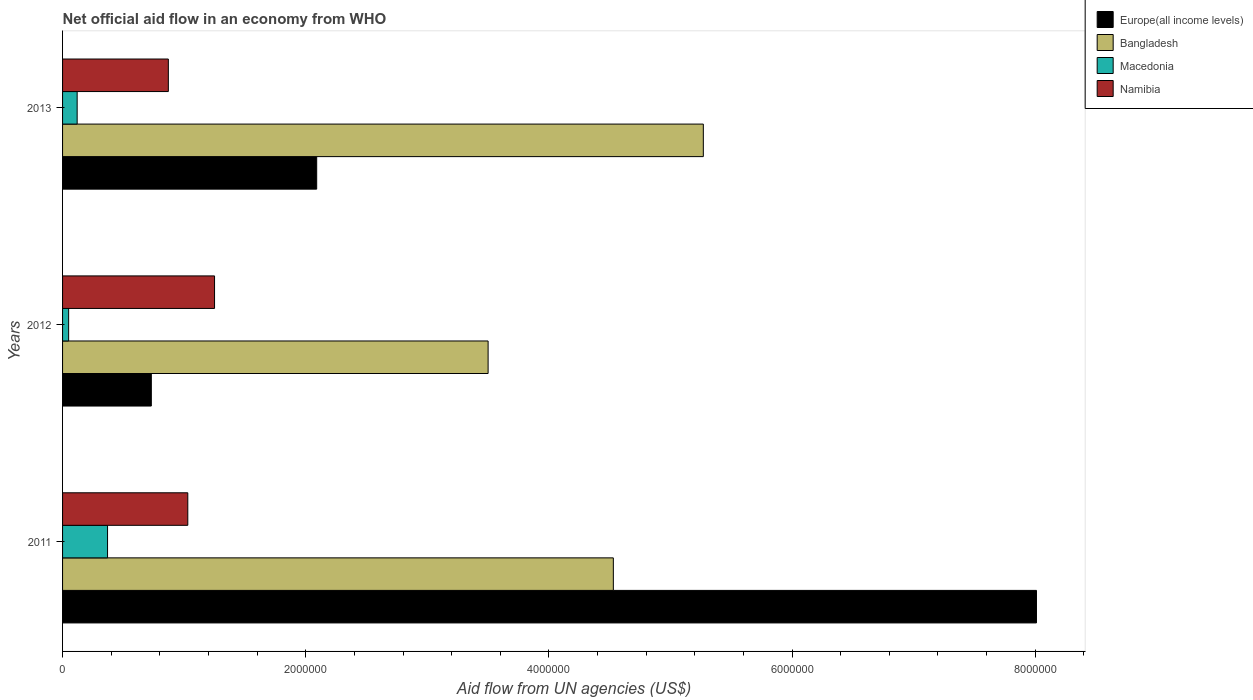Are the number of bars per tick equal to the number of legend labels?
Offer a very short reply. Yes. How many bars are there on the 1st tick from the bottom?
Your response must be concise. 4. What is the label of the 2nd group of bars from the top?
Make the answer very short. 2012. In how many cases, is the number of bars for a given year not equal to the number of legend labels?
Your answer should be very brief. 0. What is the net official aid flow in Europe(all income levels) in 2013?
Keep it short and to the point. 2.09e+06. Across all years, what is the maximum net official aid flow in Namibia?
Provide a short and direct response. 1.25e+06. In which year was the net official aid flow in Europe(all income levels) maximum?
Offer a very short reply. 2011. What is the total net official aid flow in Namibia in the graph?
Keep it short and to the point. 3.15e+06. What is the difference between the net official aid flow in Bangladesh in 2011 and that in 2012?
Your answer should be very brief. 1.03e+06. What is the difference between the net official aid flow in Macedonia in 2011 and the net official aid flow in Europe(all income levels) in 2013?
Offer a terse response. -1.72e+06. What is the average net official aid flow in Europe(all income levels) per year?
Give a very brief answer. 3.61e+06. In the year 2013, what is the difference between the net official aid flow in Macedonia and net official aid flow in Namibia?
Your answer should be compact. -7.50e+05. What is the ratio of the net official aid flow in Bangladesh in 2012 to that in 2013?
Your answer should be compact. 0.66. Is the net official aid flow in Bangladesh in 2012 less than that in 2013?
Provide a succinct answer. Yes. What is the difference between the highest and the second highest net official aid flow in Macedonia?
Provide a short and direct response. 2.50e+05. What is the difference between the highest and the lowest net official aid flow in Europe(all income levels)?
Provide a short and direct response. 7.28e+06. In how many years, is the net official aid flow in Macedonia greater than the average net official aid flow in Macedonia taken over all years?
Ensure brevity in your answer.  1. Is it the case that in every year, the sum of the net official aid flow in Bangladesh and net official aid flow in Namibia is greater than the sum of net official aid flow in Europe(all income levels) and net official aid flow in Macedonia?
Provide a short and direct response. Yes. What does the 1st bar from the top in 2012 represents?
Your response must be concise. Namibia. What does the 1st bar from the bottom in 2012 represents?
Your answer should be very brief. Europe(all income levels). How many bars are there?
Your response must be concise. 12. Are all the bars in the graph horizontal?
Keep it short and to the point. Yes. How many years are there in the graph?
Make the answer very short. 3. Are the values on the major ticks of X-axis written in scientific E-notation?
Give a very brief answer. No. Does the graph contain any zero values?
Your answer should be compact. No. Does the graph contain grids?
Make the answer very short. No. What is the title of the graph?
Keep it short and to the point. Net official aid flow in an economy from WHO. Does "Jordan" appear as one of the legend labels in the graph?
Your answer should be very brief. No. What is the label or title of the X-axis?
Offer a very short reply. Aid flow from UN agencies (US$). What is the Aid flow from UN agencies (US$) of Europe(all income levels) in 2011?
Keep it short and to the point. 8.01e+06. What is the Aid flow from UN agencies (US$) of Bangladesh in 2011?
Ensure brevity in your answer.  4.53e+06. What is the Aid flow from UN agencies (US$) of Namibia in 2011?
Ensure brevity in your answer.  1.03e+06. What is the Aid flow from UN agencies (US$) in Europe(all income levels) in 2012?
Give a very brief answer. 7.30e+05. What is the Aid flow from UN agencies (US$) in Bangladesh in 2012?
Keep it short and to the point. 3.50e+06. What is the Aid flow from UN agencies (US$) of Namibia in 2012?
Keep it short and to the point. 1.25e+06. What is the Aid flow from UN agencies (US$) in Europe(all income levels) in 2013?
Your response must be concise. 2.09e+06. What is the Aid flow from UN agencies (US$) of Bangladesh in 2013?
Your answer should be very brief. 5.27e+06. What is the Aid flow from UN agencies (US$) in Namibia in 2013?
Make the answer very short. 8.70e+05. Across all years, what is the maximum Aid flow from UN agencies (US$) in Europe(all income levels)?
Give a very brief answer. 8.01e+06. Across all years, what is the maximum Aid flow from UN agencies (US$) of Bangladesh?
Provide a short and direct response. 5.27e+06. Across all years, what is the maximum Aid flow from UN agencies (US$) in Namibia?
Give a very brief answer. 1.25e+06. Across all years, what is the minimum Aid flow from UN agencies (US$) in Europe(all income levels)?
Offer a terse response. 7.30e+05. Across all years, what is the minimum Aid flow from UN agencies (US$) in Bangladesh?
Your response must be concise. 3.50e+06. Across all years, what is the minimum Aid flow from UN agencies (US$) in Macedonia?
Offer a terse response. 5.00e+04. Across all years, what is the minimum Aid flow from UN agencies (US$) of Namibia?
Offer a very short reply. 8.70e+05. What is the total Aid flow from UN agencies (US$) in Europe(all income levels) in the graph?
Provide a short and direct response. 1.08e+07. What is the total Aid flow from UN agencies (US$) in Bangladesh in the graph?
Your answer should be very brief. 1.33e+07. What is the total Aid flow from UN agencies (US$) in Macedonia in the graph?
Your answer should be very brief. 5.40e+05. What is the total Aid flow from UN agencies (US$) of Namibia in the graph?
Make the answer very short. 3.15e+06. What is the difference between the Aid flow from UN agencies (US$) in Europe(all income levels) in 2011 and that in 2012?
Make the answer very short. 7.28e+06. What is the difference between the Aid flow from UN agencies (US$) in Bangladesh in 2011 and that in 2012?
Provide a short and direct response. 1.03e+06. What is the difference between the Aid flow from UN agencies (US$) in Europe(all income levels) in 2011 and that in 2013?
Ensure brevity in your answer.  5.92e+06. What is the difference between the Aid flow from UN agencies (US$) in Bangladesh in 2011 and that in 2013?
Make the answer very short. -7.40e+05. What is the difference between the Aid flow from UN agencies (US$) in Namibia in 2011 and that in 2013?
Keep it short and to the point. 1.60e+05. What is the difference between the Aid flow from UN agencies (US$) in Europe(all income levels) in 2012 and that in 2013?
Your answer should be very brief. -1.36e+06. What is the difference between the Aid flow from UN agencies (US$) of Bangladesh in 2012 and that in 2013?
Keep it short and to the point. -1.77e+06. What is the difference between the Aid flow from UN agencies (US$) in Macedonia in 2012 and that in 2013?
Offer a very short reply. -7.00e+04. What is the difference between the Aid flow from UN agencies (US$) in Europe(all income levels) in 2011 and the Aid flow from UN agencies (US$) in Bangladesh in 2012?
Offer a terse response. 4.51e+06. What is the difference between the Aid flow from UN agencies (US$) of Europe(all income levels) in 2011 and the Aid flow from UN agencies (US$) of Macedonia in 2012?
Offer a very short reply. 7.96e+06. What is the difference between the Aid flow from UN agencies (US$) of Europe(all income levels) in 2011 and the Aid flow from UN agencies (US$) of Namibia in 2012?
Make the answer very short. 6.76e+06. What is the difference between the Aid flow from UN agencies (US$) in Bangladesh in 2011 and the Aid flow from UN agencies (US$) in Macedonia in 2012?
Ensure brevity in your answer.  4.48e+06. What is the difference between the Aid flow from UN agencies (US$) of Bangladesh in 2011 and the Aid flow from UN agencies (US$) of Namibia in 2012?
Provide a short and direct response. 3.28e+06. What is the difference between the Aid flow from UN agencies (US$) in Macedonia in 2011 and the Aid flow from UN agencies (US$) in Namibia in 2012?
Provide a succinct answer. -8.80e+05. What is the difference between the Aid flow from UN agencies (US$) of Europe(all income levels) in 2011 and the Aid flow from UN agencies (US$) of Bangladesh in 2013?
Your response must be concise. 2.74e+06. What is the difference between the Aid flow from UN agencies (US$) in Europe(all income levels) in 2011 and the Aid flow from UN agencies (US$) in Macedonia in 2013?
Your answer should be very brief. 7.89e+06. What is the difference between the Aid flow from UN agencies (US$) of Europe(all income levels) in 2011 and the Aid flow from UN agencies (US$) of Namibia in 2013?
Your answer should be very brief. 7.14e+06. What is the difference between the Aid flow from UN agencies (US$) in Bangladesh in 2011 and the Aid flow from UN agencies (US$) in Macedonia in 2013?
Provide a succinct answer. 4.41e+06. What is the difference between the Aid flow from UN agencies (US$) in Bangladesh in 2011 and the Aid flow from UN agencies (US$) in Namibia in 2013?
Provide a short and direct response. 3.66e+06. What is the difference between the Aid flow from UN agencies (US$) in Macedonia in 2011 and the Aid flow from UN agencies (US$) in Namibia in 2013?
Offer a very short reply. -5.00e+05. What is the difference between the Aid flow from UN agencies (US$) in Europe(all income levels) in 2012 and the Aid flow from UN agencies (US$) in Bangladesh in 2013?
Give a very brief answer. -4.54e+06. What is the difference between the Aid flow from UN agencies (US$) in Europe(all income levels) in 2012 and the Aid flow from UN agencies (US$) in Macedonia in 2013?
Keep it short and to the point. 6.10e+05. What is the difference between the Aid flow from UN agencies (US$) of Bangladesh in 2012 and the Aid flow from UN agencies (US$) of Macedonia in 2013?
Provide a short and direct response. 3.38e+06. What is the difference between the Aid flow from UN agencies (US$) in Bangladesh in 2012 and the Aid flow from UN agencies (US$) in Namibia in 2013?
Your answer should be very brief. 2.63e+06. What is the difference between the Aid flow from UN agencies (US$) of Macedonia in 2012 and the Aid flow from UN agencies (US$) of Namibia in 2013?
Offer a terse response. -8.20e+05. What is the average Aid flow from UN agencies (US$) in Europe(all income levels) per year?
Provide a succinct answer. 3.61e+06. What is the average Aid flow from UN agencies (US$) in Bangladesh per year?
Keep it short and to the point. 4.43e+06. What is the average Aid flow from UN agencies (US$) of Namibia per year?
Your response must be concise. 1.05e+06. In the year 2011, what is the difference between the Aid flow from UN agencies (US$) in Europe(all income levels) and Aid flow from UN agencies (US$) in Bangladesh?
Your answer should be very brief. 3.48e+06. In the year 2011, what is the difference between the Aid flow from UN agencies (US$) in Europe(all income levels) and Aid flow from UN agencies (US$) in Macedonia?
Ensure brevity in your answer.  7.64e+06. In the year 2011, what is the difference between the Aid flow from UN agencies (US$) of Europe(all income levels) and Aid flow from UN agencies (US$) of Namibia?
Provide a succinct answer. 6.98e+06. In the year 2011, what is the difference between the Aid flow from UN agencies (US$) of Bangladesh and Aid flow from UN agencies (US$) of Macedonia?
Make the answer very short. 4.16e+06. In the year 2011, what is the difference between the Aid flow from UN agencies (US$) of Bangladesh and Aid flow from UN agencies (US$) of Namibia?
Your response must be concise. 3.50e+06. In the year 2011, what is the difference between the Aid flow from UN agencies (US$) of Macedonia and Aid flow from UN agencies (US$) of Namibia?
Keep it short and to the point. -6.60e+05. In the year 2012, what is the difference between the Aid flow from UN agencies (US$) of Europe(all income levels) and Aid flow from UN agencies (US$) of Bangladesh?
Provide a short and direct response. -2.77e+06. In the year 2012, what is the difference between the Aid flow from UN agencies (US$) of Europe(all income levels) and Aid flow from UN agencies (US$) of Macedonia?
Offer a very short reply. 6.80e+05. In the year 2012, what is the difference between the Aid flow from UN agencies (US$) in Europe(all income levels) and Aid flow from UN agencies (US$) in Namibia?
Keep it short and to the point. -5.20e+05. In the year 2012, what is the difference between the Aid flow from UN agencies (US$) of Bangladesh and Aid flow from UN agencies (US$) of Macedonia?
Provide a short and direct response. 3.45e+06. In the year 2012, what is the difference between the Aid flow from UN agencies (US$) of Bangladesh and Aid flow from UN agencies (US$) of Namibia?
Give a very brief answer. 2.25e+06. In the year 2012, what is the difference between the Aid flow from UN agencies (US$) of Macedonia and Aid flow from UN agencies (US$) of Namibia?
Your answer should be compact. -1.20e+06. In the year 2013, what is the difference between the Aid flow from UN agencies (US$) of Europe(all income levels) and Aid flow from UN agencies (US$) of Bangladesh?
Your response must be concise. -3.18e+06. In the year 2013, what is the difference between the Aid flow from UN agencies (US$) of Europe(all income levels) and Aid flow from UN agencies (US$) of Macedonia?
Give a very brief answer. 1.97e+06. In the year 2013, what is the difference between the Aid flow from UN agencies (US$) of Europe(all income levels) and Aid flow from UN agencies (US$) of Namibia?
Ensure brevity in your answer.  1.22e+06. In the year 2013, what is the difference between the Aid flow from UN agencies (US$) in Bangladesh and Aid flow from UN agencies (US$) in Macedonia?
Your response must be concise. 5.15e+06. In the year 2013, what is the difference between the Aid flow from UN agencies (US$) of Bangladesh and Aid flow from UN agencies (US$) of Namibia?
Your answer should be very brief. 4.40e+06. In the year 2013, what is the difference between the Aid flow from UN agencies (US$) in Macedonia and Aid flow from UN agencies (US$) in Namibia?
Make the answer very short. -7.50e+05. What is the ratio of the Aid flow from UN agencies (US$) of Europe(all income levels) in 2011 to that in 2012?
Ensure brevity in your answer.  10.97. What is the ratio of the Aid flow from UN agencies (US$) of Bangladesh in 2011 to that in 2012?
Provide a succinct answer. 1.29. What is the ratio of the Aid flow from UN agencies (US$) of Namibia in 2011 to that in 2012?
Provide a succinct answer. 0.82. What is the ratio of the Aid flow from UN agencies (US$) of Europe(all income levels) in 2011 to that in 2013?
Make the answer very short. 3.83. What is the ratio of the Aid flow from UN agencies (US$) of Bangladesh in 2011 to that in 2013?
Provide a succinct answer. 0.86. What is the ratio of the Aid flow from UN agencies (US$) of Macedonia in 2011 to that in 2013?
Your response must be concise. 3.08. What is the ratio of the Aid flow from UN agencies (US$) of Namibia in 2011 to that in 2013?
Make the answer very short. 1.18. What is the ratio of the Aid flow from UN agencies (US$) in Europe(all income levels) in 2012 to that in 2013?
Your response must be concise. 0.35. What is the ratio of the Aid flow from UN agencies (US$) of Bangladesh in 2012 to that in 2013?
Make the answer very short. 0.66. What is the ratio of the Aid flow from UN agencies (US$) of Macedonia in 2012 to that in 2013?
Your answer should be very brief. 0.42. What is the ratio of the Aid flow from UN agencies (US$) of Namibia in 2012 to that in 2013?
Give a very brief answer. 1.44. What is the difference between the highest and the second highest Aid flow from UN agencies (US$) in Europe(all income levels)?
Your answer should be compact. 5.92e+06. What is the difference between the highest and the second highest Aid flow from UN agencies (US$) of Bangladesh?
Your response must be concise. 7.40e+05. What is the difference between the highest and the lowest Aid flow from UN agencies (US$) in Europe(all income levels)?
Offer a very short reply. 7.28e+06. What is the difference between the highest and the lowest Aid flow from UN agencies (US$) in Bangladesh?
Your answer should be compact. 1.77e+06. What is the difference between the highest and the lowest Aid flow from UN agencies (US$) of Macedonia?
Provide a short and direct response. 3.20e+05. 